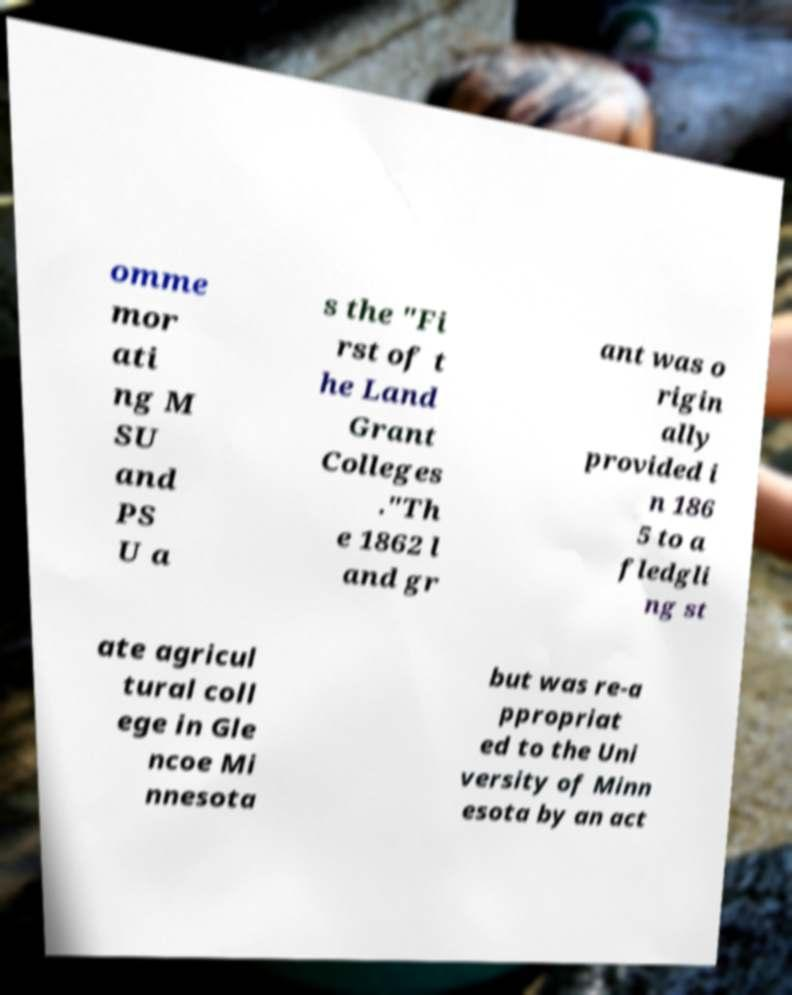Please read and relay the text visible in this image. What does it say? omme mor ati ng M SU and PS U a s the "Fi rst of t he Land Grant Colleges ."Th e 1862 l and gr ant was o rigin ally provided i n 186 5 to a fledgli ng st ate agricul tural coll ege in Gle ncoe Mi nnesota but was re-a ppropriat ed to the Uni versity of Minn esota by an act 